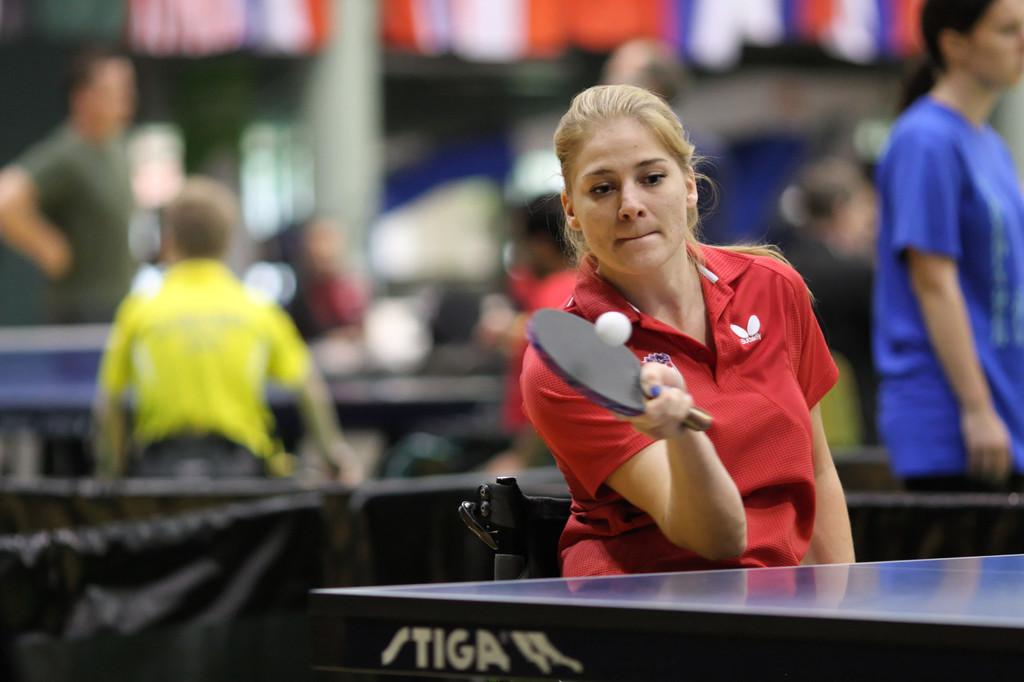What activity is the woman in the image engaged in? The woman is playing table tennis in the image. Can you describe the setting of the image? There are other persons standing in the background, and there is a pole visible in the image. What type of island can be seen in the background of the image? There is no island visible in the image; it is focused on the woman playing table tennis and the surrounding elements. 